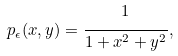Convert formula to latex. <formula><loc_0><loc_0><loc_500><loc_500>p _ { \epsilon } ( x , y ) = \cfrac { 1 } { 1 + x ^ { 2 } + y ^ { 2 } } \, ,</formula> 